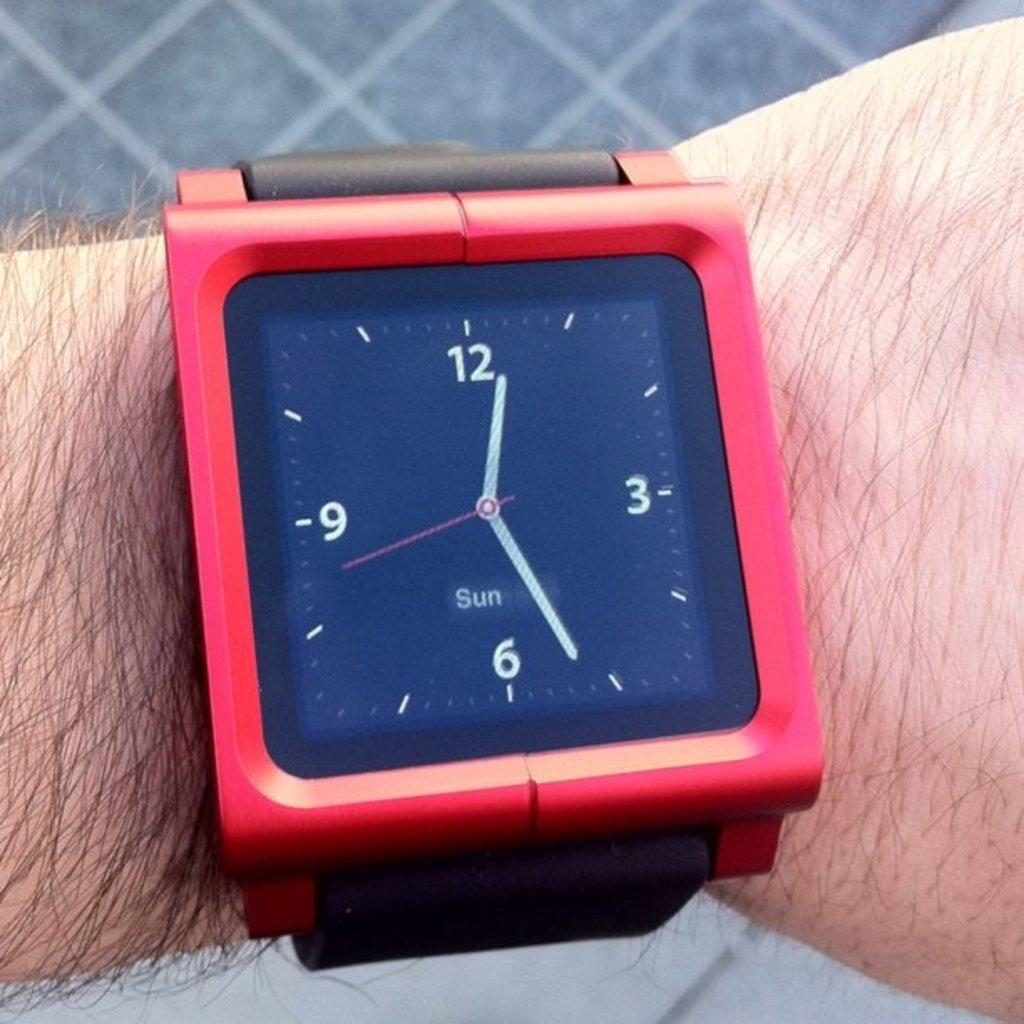<image>
Create a compact narrative representing the image presented. The red watch on the persons arm says 12:26. 